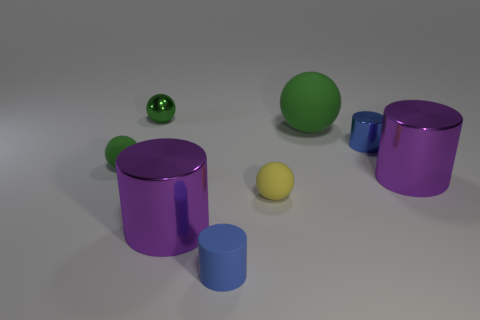There is another blue cylinder that is the same size as the matte cylinder; what material is it?
Your response must be concise. Metal. How many metal objects are large purple objects or cylinders?
Offer a very short reply. 3. There is a small cylinder that is behind the blue thing in front of the small yellow sphere; how many green shiny spheres are in front of it?
Offer a very short reply. 0. How many other spheres are the same color as the shiny sphere?
Offer a terse response. 2. Is the size of the purple thing to the right of the yellow ball the same as the large green sphere?
Your answer should be very brief. Yes. What is the color of the big object that is both in front of the blue metal thing and right of the yellow object?
Provide a short and direct response. Purple. What number of objects are green things or big green rubber things that are right of the small yellow object?
Make the answer very short. 3. What material is the tiny ball that is on the right side of the small cylinder that is in front of the green sphere on the left side of the green metallic thing?
Give a very brief answer. Rubber. There is a tiny object behind the large rubber thing; does it have the same color as the big rubber ball?
Offer a terse response. Yes. How many cyan things are tiny matte things or big matte objects?
Make the answer very short. 0. 